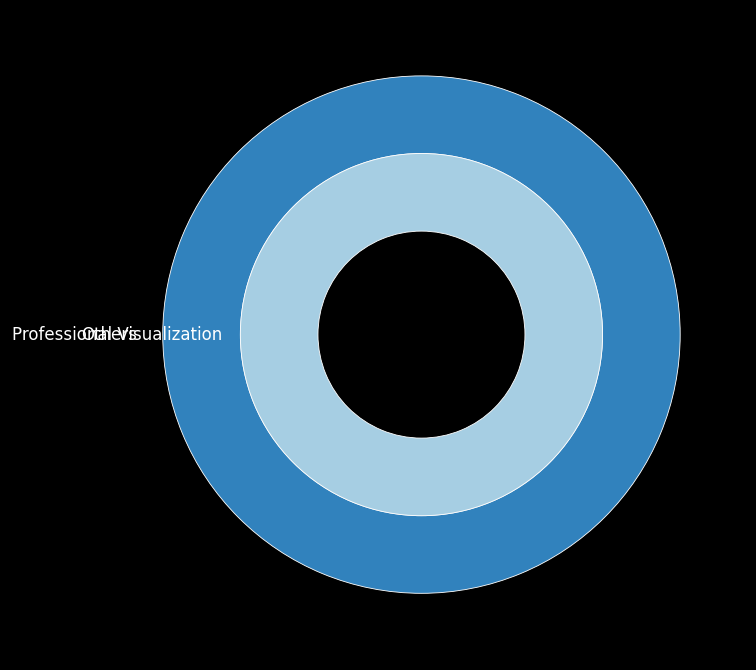What company holds the largest market share? By looking at the outer ring of the nested pie chart, the size of each company's segment represents its total market share across all segments. The company with the largest segment has the biggest market share.
Answer: [Answer based on figure] How does the market share for professional visualization compare between the companies? Identify the sections of the inner ring labeled as professional visualization. Look at the size of these sections within the overall nested pie chart and compare their sizes visually.
Answer: [Answer based on figure] Which company has the smallest segment in the data center market? Locate the small slices within the inner ring section labeled "data centers" and compare their sizes. The company with the smallest slice represents the smallest segment.
Answer: [Answer based on figure] What is the total market share for gaming across all companies? Sum up all the visible sections labeled "gaming" from the inner ring by evaluating their relative sizes to estimate the overall percentage.
Answer: [Answer based on figure] Compare the market shares of Company A in the data center and gaming segments. Identify the sections corresponding to Company A's market share in the inner ring for both data center and gaming segments. Visually compare the sizes to determine which is larger.
Answer: [Answer based on figure] Based on the pie chart, which GPU market segment appears to be the most competitive? The most competitive segment will have a more even distribution of market shares among different companies. Look for the segment in the inner ring with several nearly equal-sized sections.
Answer: [Answer based on figure] 